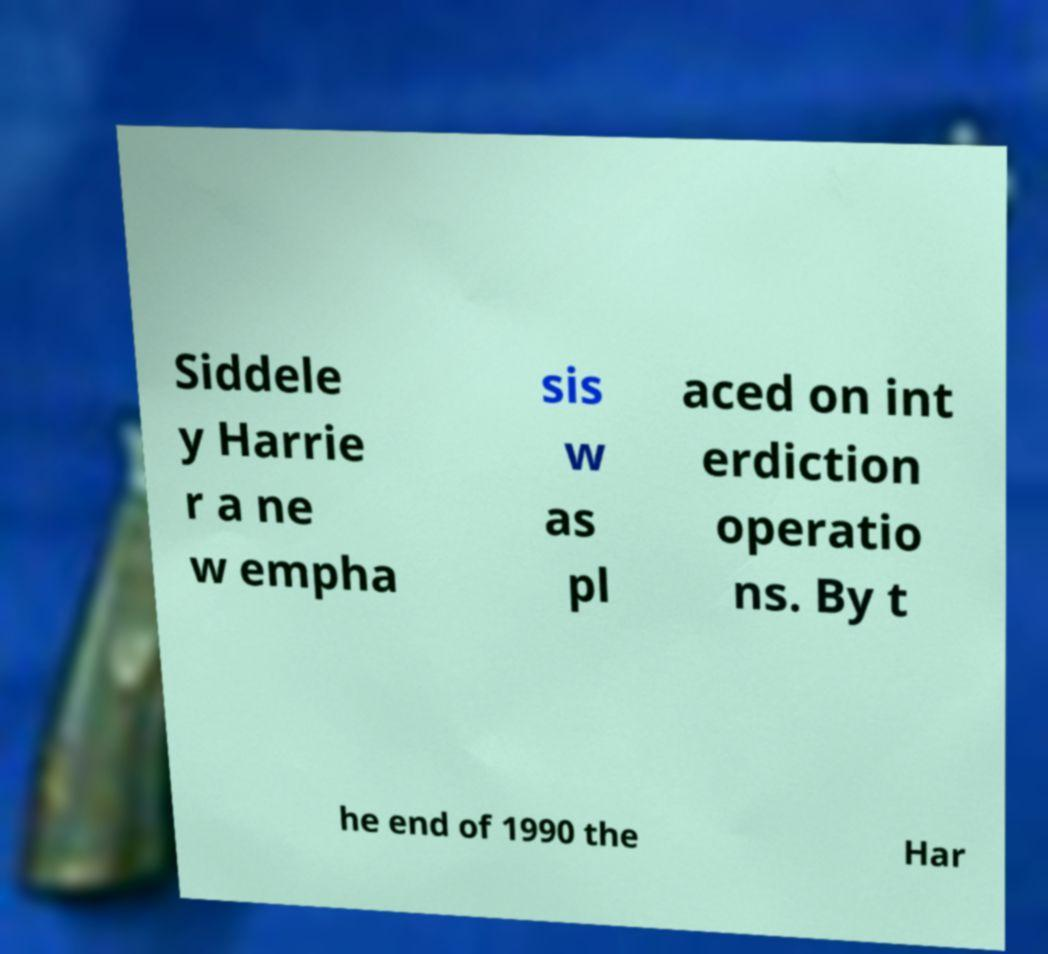Could you extract and type out the text from this image? Siddele y Harrie r a ne w empha sis w as pl aced on int erdiction operatio ns. By t he end of 1990 the Har 